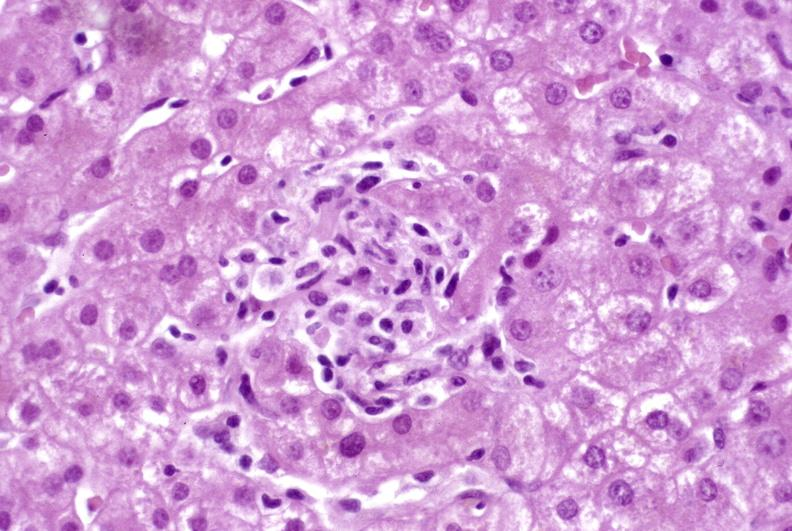does granuloma show granulomas?
Answer the question using a single word or phrase. No 